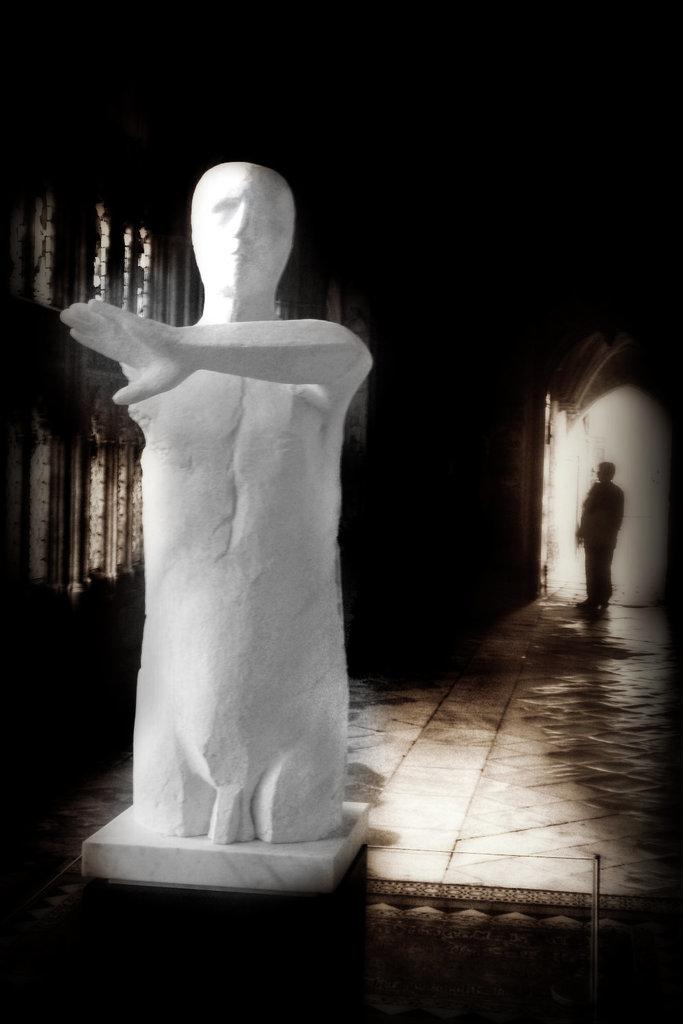What is the main subject on the left side of the image? There is a white color sculpture on the left side of the image. What can be seen behind the sculpture? There are windows behind the sculpture. Can you describe the background of the image? The background of the image features a person standing, but their clarity is uncertain. What type of collar is the cub wearing in the image? There is no cub or collar present in the image. 